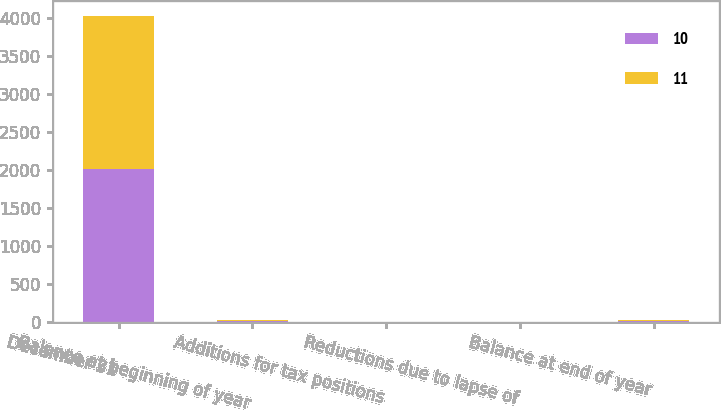Convert chart to OTSL. <chart><loc_0><loc_0><loc_500><loc_500><stacked_bar_chart><ecel><fcel>December 31<fcel>Balance at beginning of year<fcel>Additions for tax positions<fcel>Reductions due to lapse of<fcel>Balance at end of year<nl><fcel>10<fcel>2014<fcel>10<fcel>1<fcel>1<fcel>11<nl><fcel>11<fcel>2013<fcel>12<fcel>1<fcel>2<fcel>10<nl></chart> 